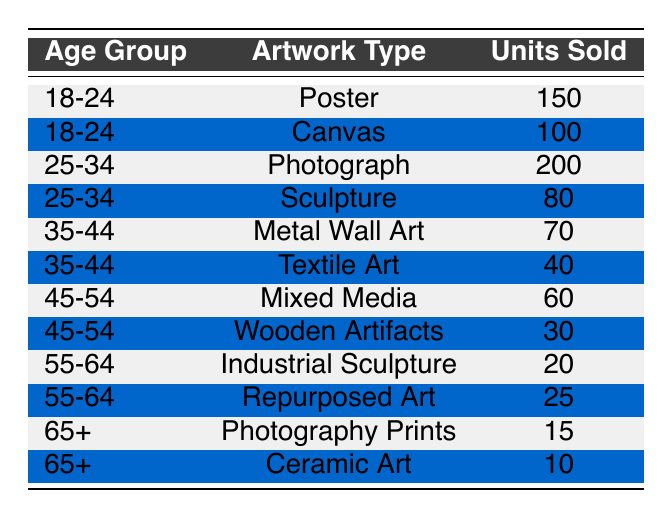What is the total number of units sold for the age group 18-24? From the table, we see that for the age group 18-24, the units sold are 150 for Posters and 100 for Canvas. Adding these together gives us 150 + 100 = 250.
Answer: 250 Which artwork type sold the most units in the age group 25-34? In the age group 25-34, the data shows that Photographs sold 200 units and Sculptures sold 80 units. Since 200 is greater than 80, Photographs sold the most.
Answer: Photograph Is there any artwork type that sold less than 30 units in any age group? Looking at the data, we find that Wooden Artifacts sold 30 units and both Photography Prints (15 units) and Ceramic Art (10 units) sold less than 30. Therefore, the answer is yes.
Answer: Yes What is the average number of units sold for the age group 35-44? For age group 35-44, the units sold are 70 for Metal Wall Art and 40 for Textile Art. The total units sold is 70 + 40 = 110. There are 2 artworks, so the average is 110 / 2 = 55.
Answer: 55 Which age group had the least number of units sold in total? To determine this, we sum up the units sold for each age group: 18-24: 250, 25-34: 280, 35-44: 110, 45-54: 90, 55-64: 45, 65+: 25. The least total is for the age group 65+, which sold 25 units.
Answer: 65+ What is the difference in total units sold between the age groups 25-34 and 45-54? First, we calculate the total units for 25-34: 200 (Photograph) + 80 (Sculpture) = 280. For 45-54, it is 60 (Mixed Media) + 30 (Wooden Artifacts) = 90. The difference is 280 - 90 = 190.
Answer: 190 Did the 55-64 age group sell more units in Repurposed Art compared to Industrial Sculpture? The table shows that Repurposed Art sold 25 units while Industrial Sculpture sold 20 units. Since 25 is greater than 20, the statement is true.
Answer: Yes What percentage of total sales does the 35-44 age group represent based on the total unit sales across all age groups? The total units sold across all groups is 250 (18-24) + 280 (25-34) + 110 (35-44) + 90 (45-54) + 45 (55-64) + 25 (65+) = 800. The 35-44 age group's total is 110. The percentage is (110 / 800) * 100 = 13.75%.
Answer: 13.75% 